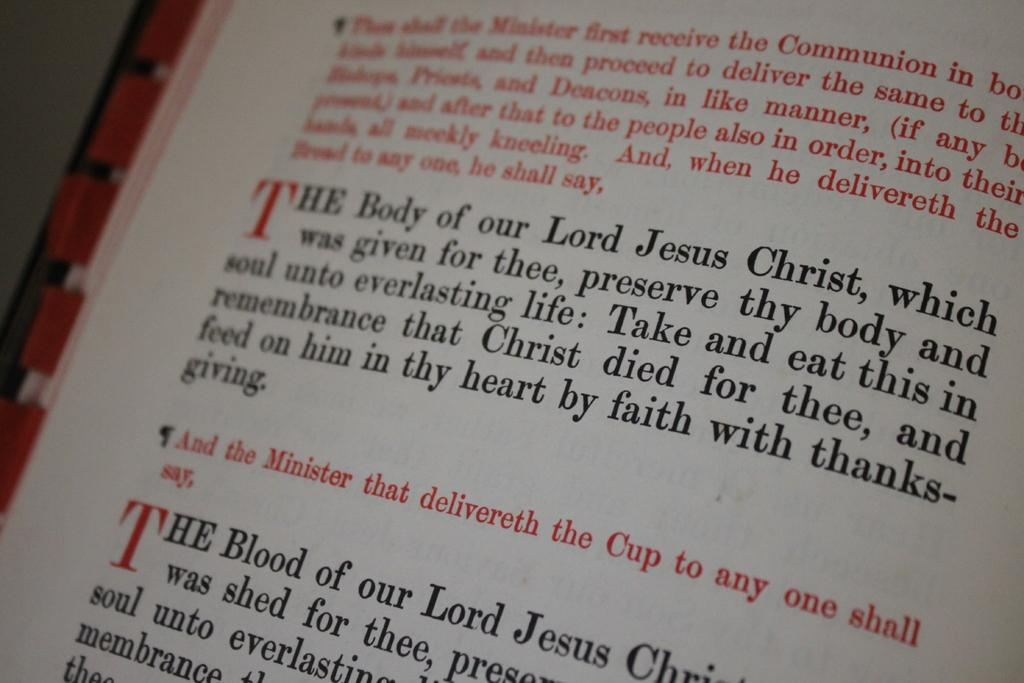<image>
Share a concise interpretation of the image provided. page of the bible with verse starting with the body of our lord jesus christ 